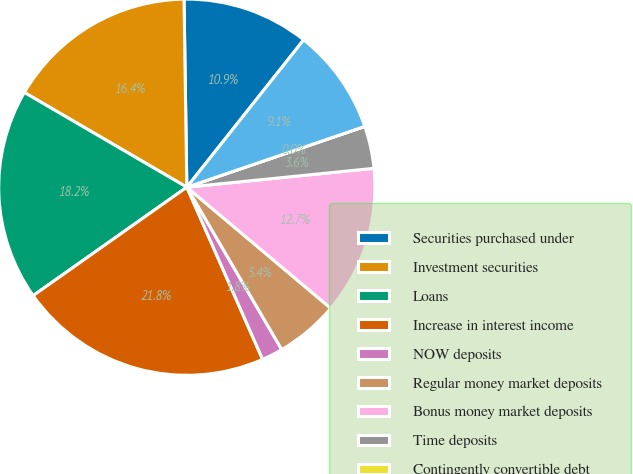Convert chart. <chart><loc_0><loc_0><loc_500><loc_500><pie_chart><fcel>Securities purchased under<fcel>Investment securities<fcel>Loans<fcel>Increase in interest income<fcel>NOW deposits<fcel>Regular money market deposits<fcel>Bonus money market deposits<fcel>Time deposits<fcel>Contingently convertible debt<fcel>Junior subordinated debentures<nl><fcel>10.91%<fcel>16.36%<fcel>18.18%<fcel>21.82%<fcel>1.82%<fcel>5.45%<fcel>12.73%<fcel>3.64%<fcel>0.0%<fcel>9.09%<nl></chart> 